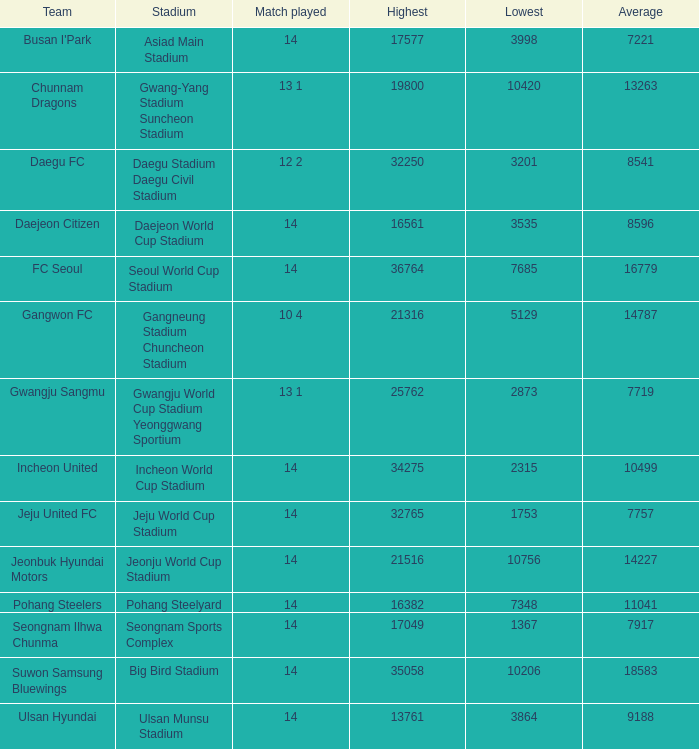What is the least when pohang steel yard is the venue? 7348.0. 